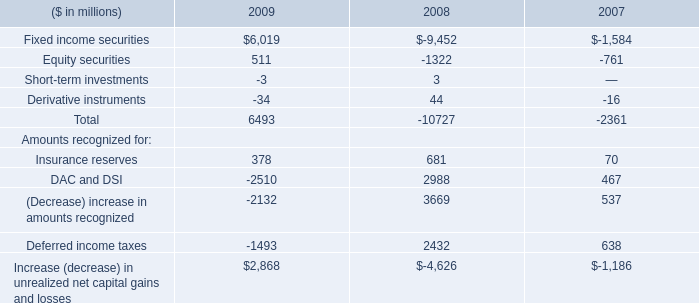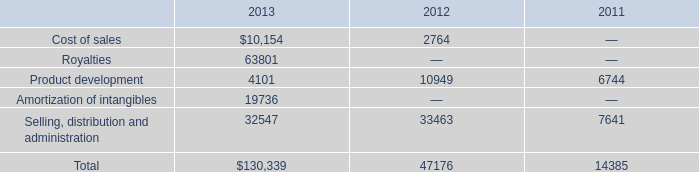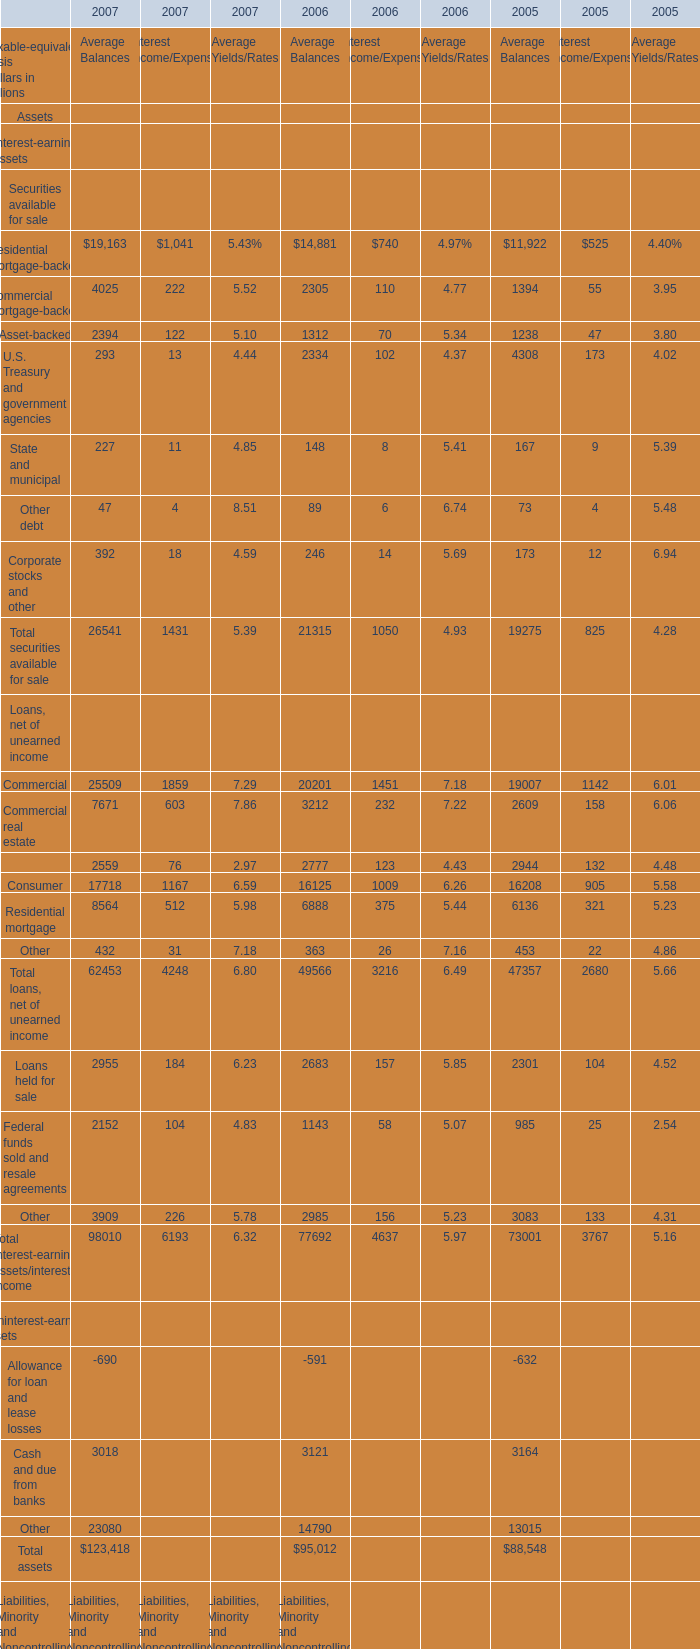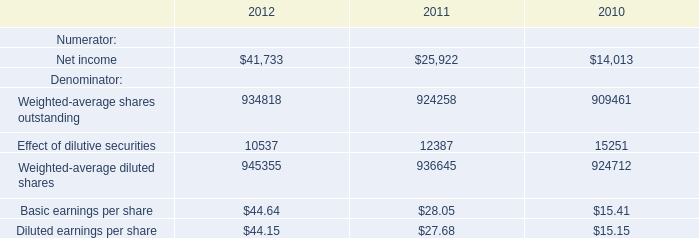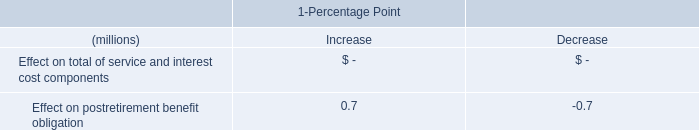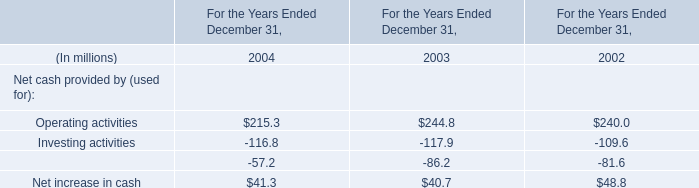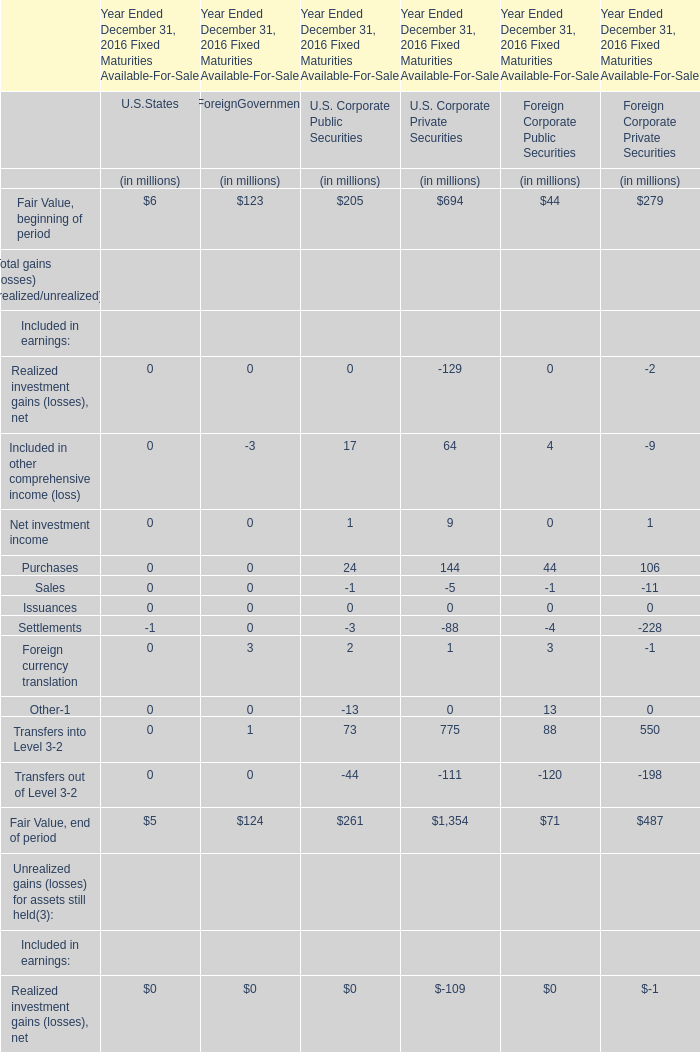As As the chart 2 shows,which year is the Interest Income for Total securities available for sale the lowest? 
Answer: 2005. 